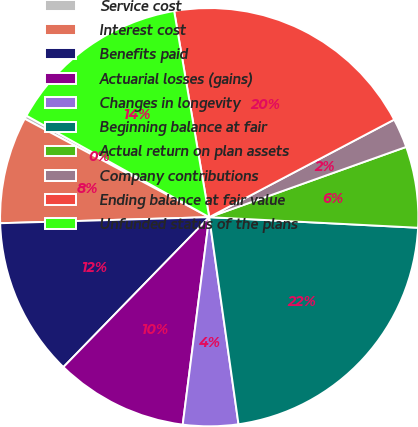<chart> <loc_0><loc_0><loc_500><loc_500><pie_chart><fcel>Service cost<fcel>Interest cost<fcel>Benefits paid<fcel>Actuarial losses (gains)<fcel>Changes in longevity<fcel>Beginning balance at fair<fcel>Actual return on plan assets<fcel>Company contributions<fcel>Ending balance at fair value<fcel>Unfunded status of the plans<nl><fcel>0.27%<fcel>8.26%<fcel>12.26%<fcel>10.26%<fcel>4.26%<fcel>21.96%<fcel>6.26%<fcel>2.27%<fcel>19.96%<fcel>14.25%<nl></chart> 